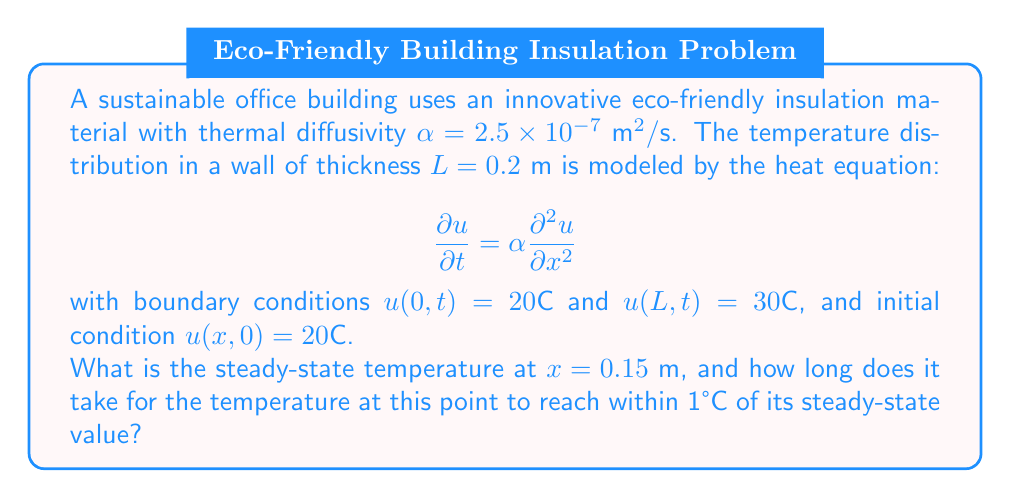Solve this math problem. Let's approach this problem step-by-step:

1) First, we need to find the steady-state solution. The steady-state heat equation is:

   $$\frac{d^2u}{dx^2} = 0$$

2) Integrating twice, we get:

   $$u(x) = Ax + B$$

3) Using the boundary conditions:
   
   $u(0) = 20°\text{C} \Rightarrow B = 20$
   $u(0.2) = 30°\text{C} \Rightarrow 0.2A + 20 = 30 \Rightarrow A = 50$

4) So, the steady-state solution is:

   $$u(x) = 50x + 20$$

5) At $x = 0.15 \text{ m}$, the steady-state temperature is:

   $$u(0.15) = 50(0.15) + 20 = 27.5°\text{C}$$

6) For the time to reach within 1°C of steady-state, we can use the solution to the heat equation:

   $$u(x,t) = 20 + 50x + \sum_{n=1}^{\infty} \frac{200}{n\pi}\sin(\frac{n\pi x}{L})e^{-\alpha(\frac{n\pi}{L})^2t}$$

7) We need to find $t$ when $u(0.15,t) \approx 26.5°\text{C}$. This is equivalent to solving:

   $$\sum_{n=1}^{\infty} \frac{200}{n\pi}\sin(\frac{n\pi 0.15}{0.2})e^{-2.5 \times 10^{-7}(\frac{n\pi}{0.2})^2t} \approx -1$$

8) This equation can't be solved analytically. However, we can estimate that the series converges quickly, and the first term dominates. So, we can approximate:

   $$\frac{200}{\pi}\sin(\frac{3\pi}{4})e^{-2.5 \times 10^{-7}(\frac{\pi}{0.2})^2t} \approx -1$$

9) Solving for $t$:

   $$t \approx -\frac{0.2^2}{2.5 \times 10^{-7}\pi^2}\ln(\frac{\pi}{200\sin(3\pi/4)}) \approx 1126 \text{ seconds}$$
Answer: 27.5°C; approximately 1126 seconds 